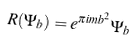Convert formula to latex. <formula><loc_0><loc_0><loc_500><loc_500>R ( \Psi _ { b } ) = e ^ { \pi i m b ^ { 2 } } \Psi _ { b }</formula> 